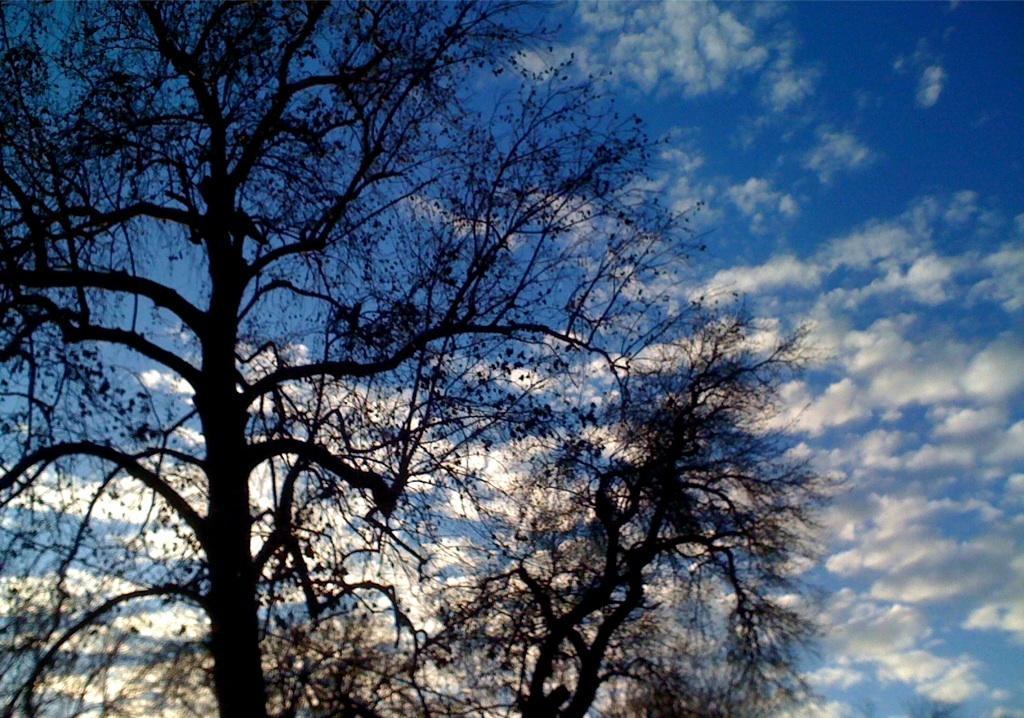Could you give a brief overview of what you see in this image? In the image there are two trees and in the background there is a sky with many clouds. 